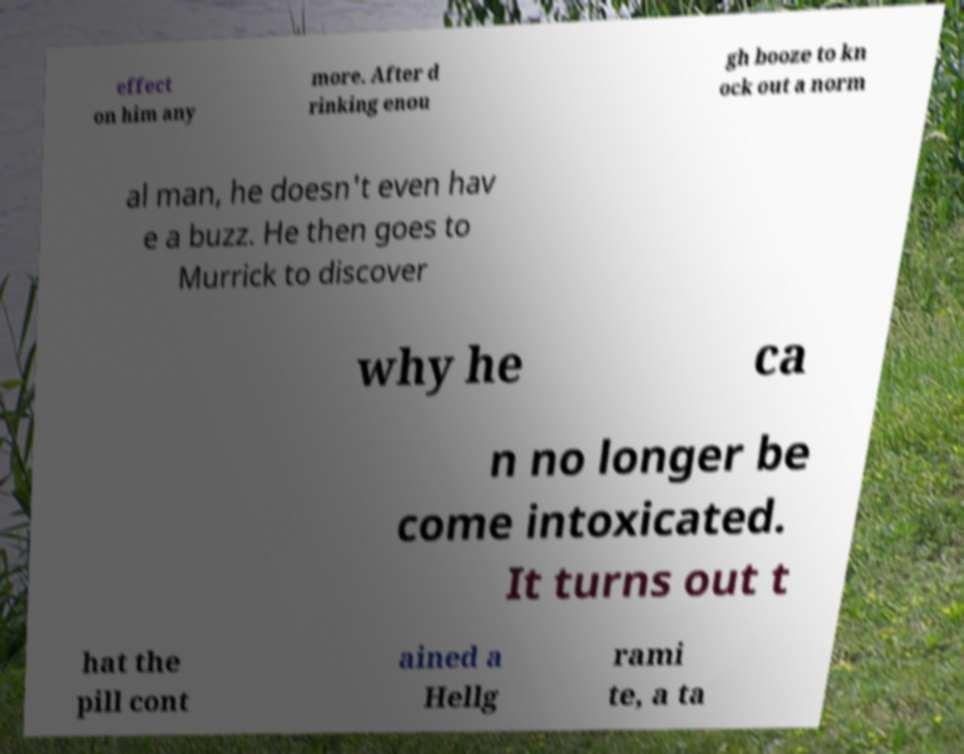I need the written content from this picture converted into text. Can you do that? effect on him any more. After d rinking enou gh booze to kn ock out a norm al man, he doesn't even hav e a buzz. He then goes to Murrick to discover why he ca n no longer be come intoxicated. It turns out t hat the pill cont ained a Hellg rami te, a ta 